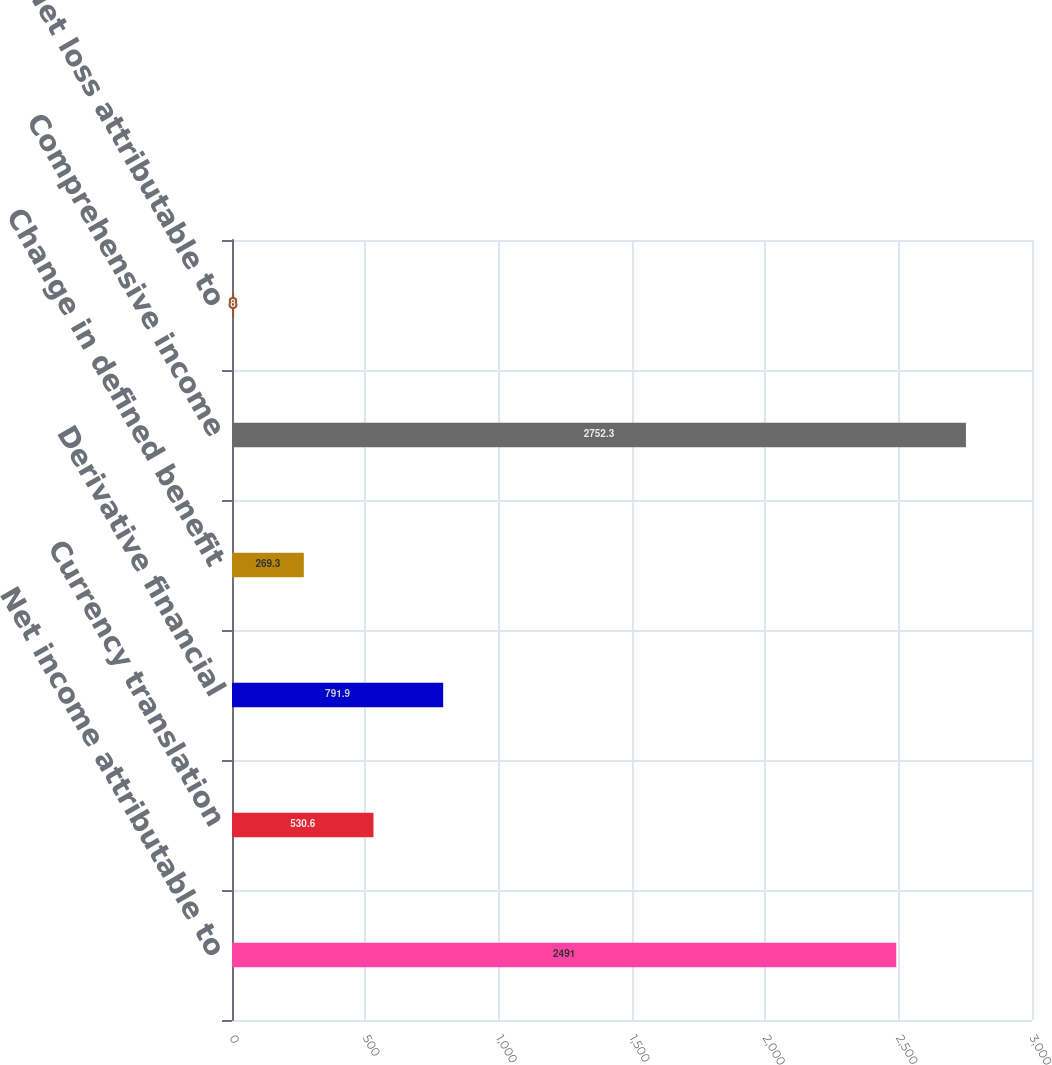Convert chart. <chart><loc_0><loc_0><loc_500><loc_500><bar_chart><fcel>Net income attributable to<fcel>Currency translation<fcel>Derivative financial<fcel>Change in defined benefit<fcel>Comprehensive income<fcel>Net loss attributable to<nl><fcel>2491<fcel>530.6<fcel>791.9<fcel>269.3<fcel>2752.3<fcel>8<nl></chart> 